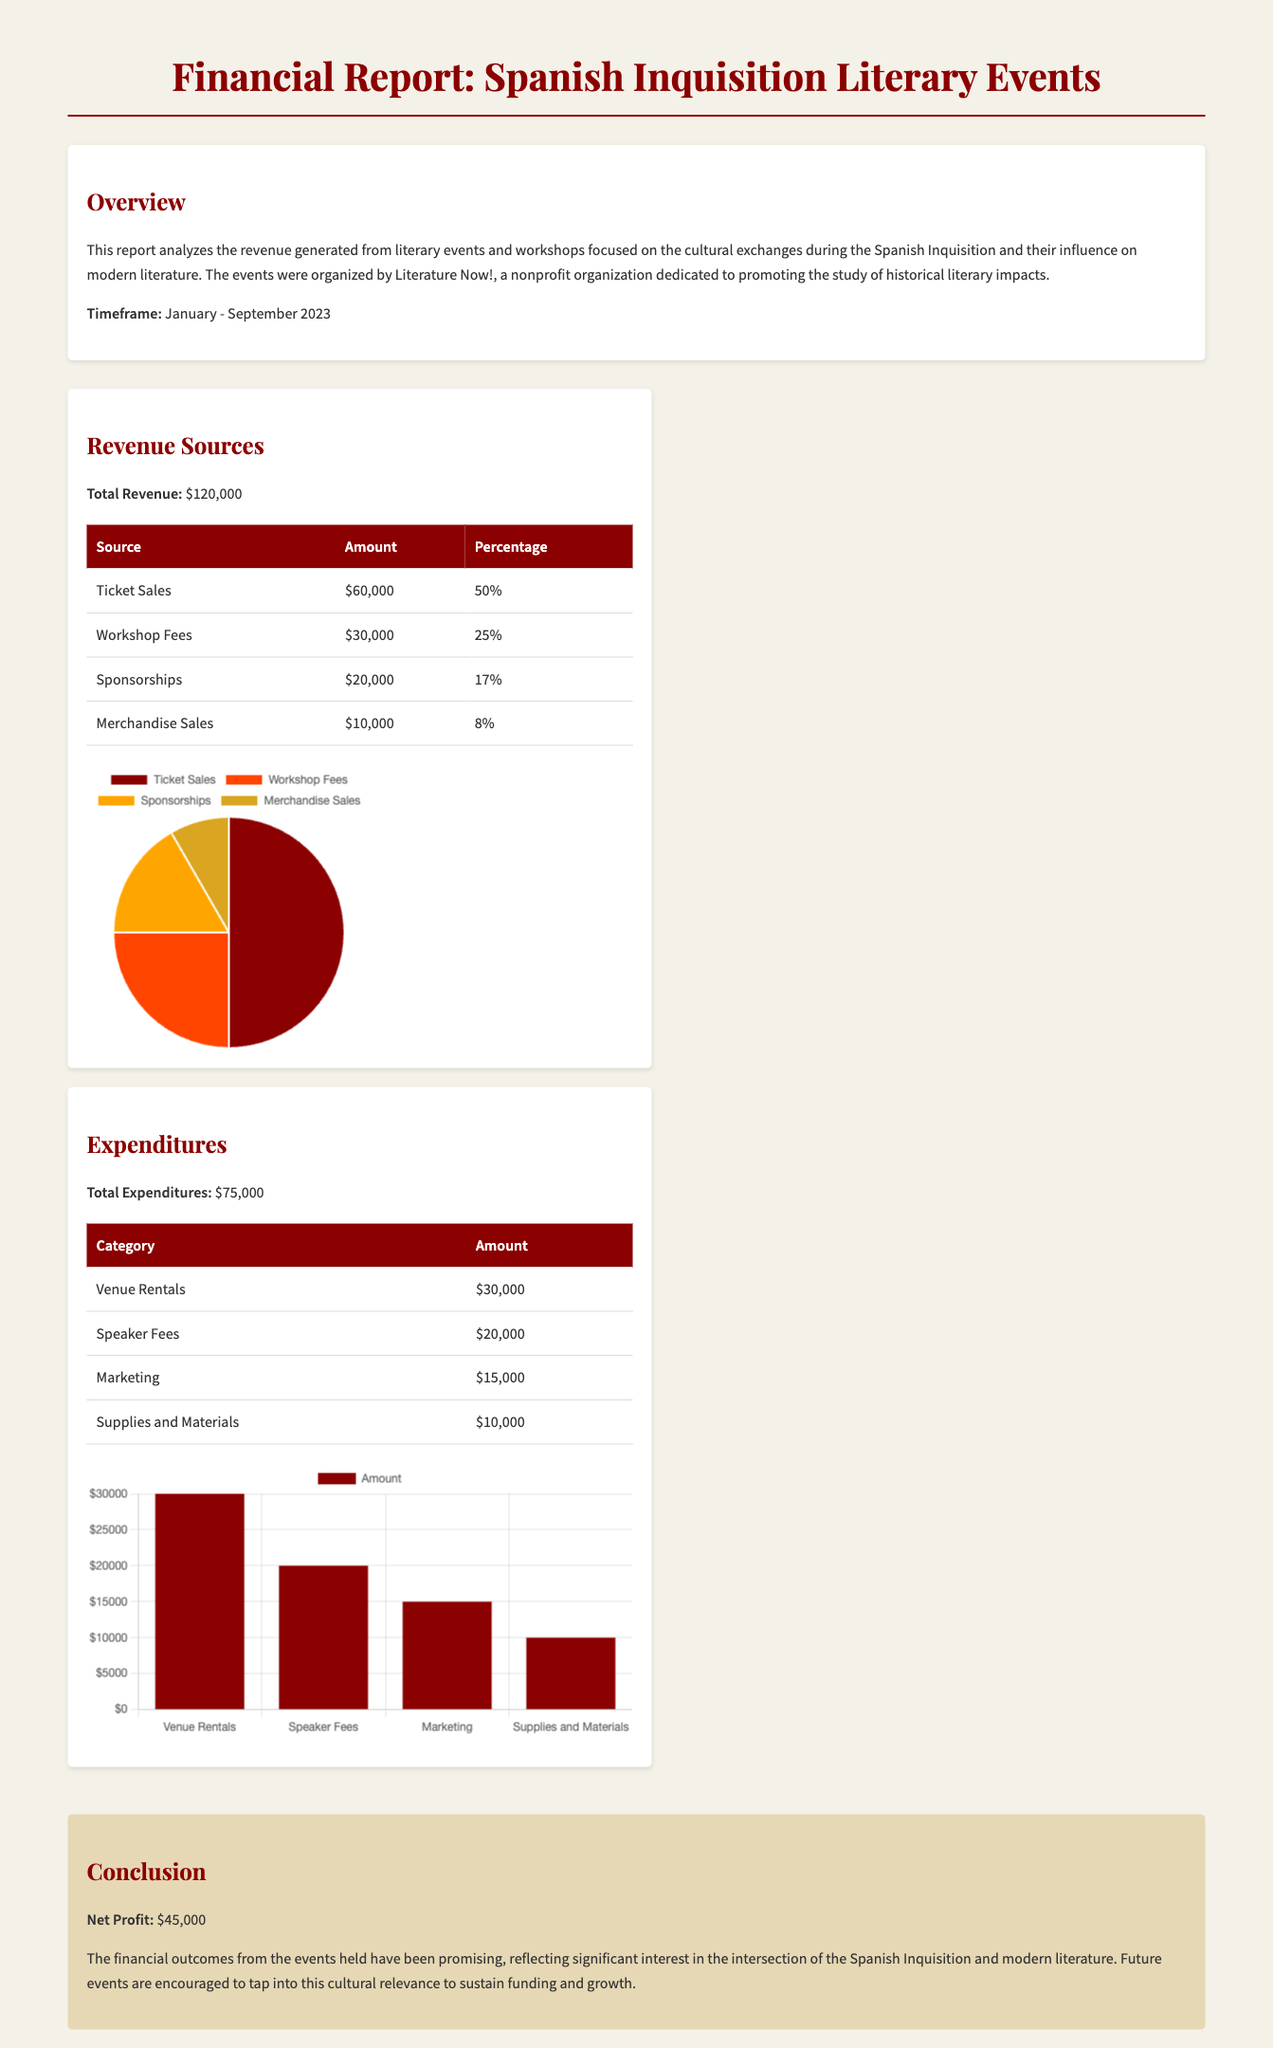what is the total revenue? The total revenue is mentioned in the financial report and is clearly defined as $120,000.
Answer: $120,000 what percentage of the total revenue comes from ticket sales? The report states that ticket sales accounted for 50% of the total revenue.
Answer: 50% what are the expenditures for speaker fees? The document lists speaker fees under expenditures with an amount of $20,000.
Answer: $20,000 what is the net profit from the events? The conclusion section provides the net profit figure, which is $45,000.
Answer: $45,000 how much revenue is generated from merchandise sales? The revenue section indicates that merchandise sales contributed $10,000 to the total revenue.
Answer: $10,000 which category has the highest expenditure? The expenditures table shows that venue rentals are the highest expenditure category at $30,000.
Answer: Venue Rentals what is the total amount spent on marketing? The expenditures table specifies the marketing cost as $15,000.
Answer: $15,000 which event organization produced the report? The report mentions "Literature Now!" as the organization that arranged the events and produced the report.
Answer: Literature Now! what timeframe does the report cover? The report explicitly states that it analyzes data from January to September 2023.
Answer: January - September 2023 